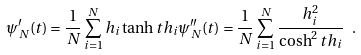Convert formula to latex. <formula><loc_0><loc_0><loc_500><loc_500>\psi ^ { \prime } _ { N } ( t ) = \frac { 1 } { N } \sum _ { i = 1 } ^ { N } h _ { i } \tanh t h _ { i } \psi _ { N } ^ { \prime \prime } ( t ) = \frac { 1 } { N } \sum _ { i = 1 } ^ { N } \frac { h _ { i } ^ { 2 } } { \cosh ^ { 2 } t h _ { i } } \ .</formula> 